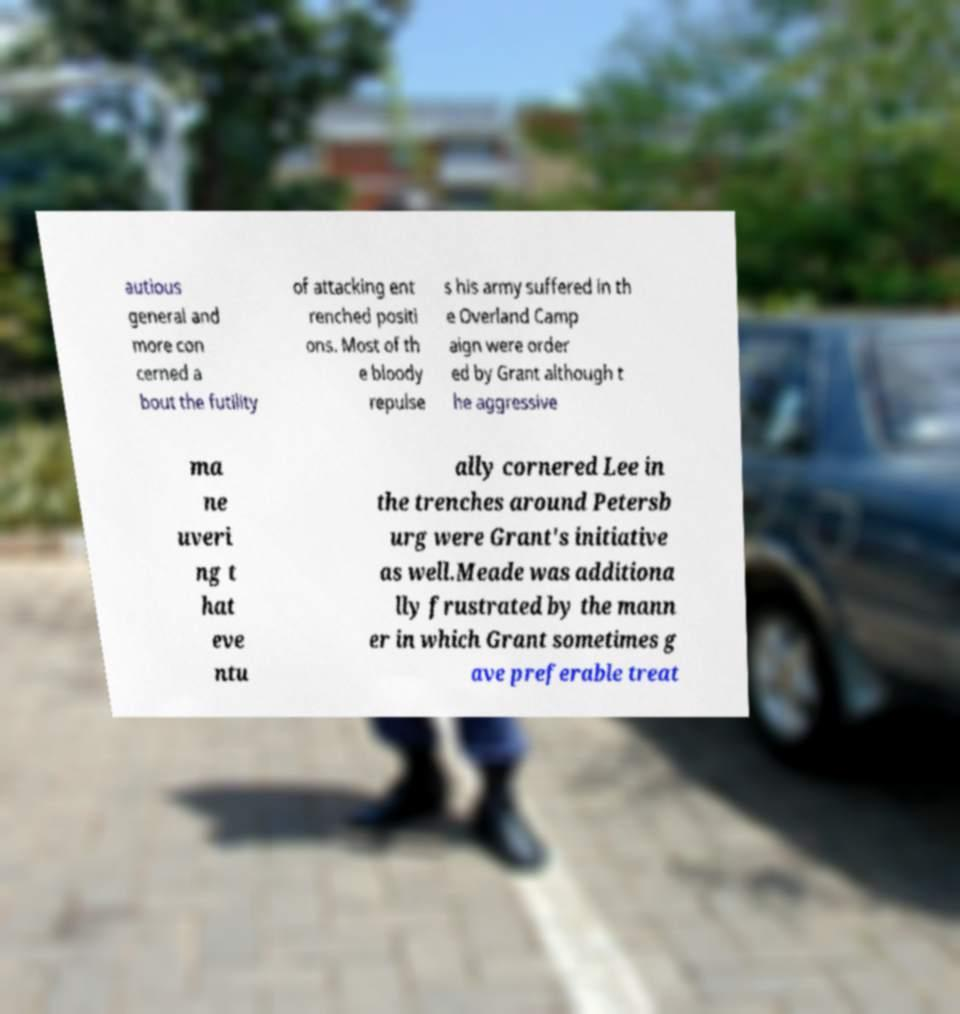Please identify and transcribe the text found in this image. autious general and more con cerned a bout the futility of attacking ent renched positi ons. Most of th e bloody repulse s his army suffered in th e Overland Camp aign were order ed by Grant although t he aggressive ma ne uveri ng t hat eve ntu ally cornered Lee in the trenches around Petersb urg were Grant's initiative as well.Meade was additiona lly frustrated by the mann er in which Grant sometimes g ave preferable treat 